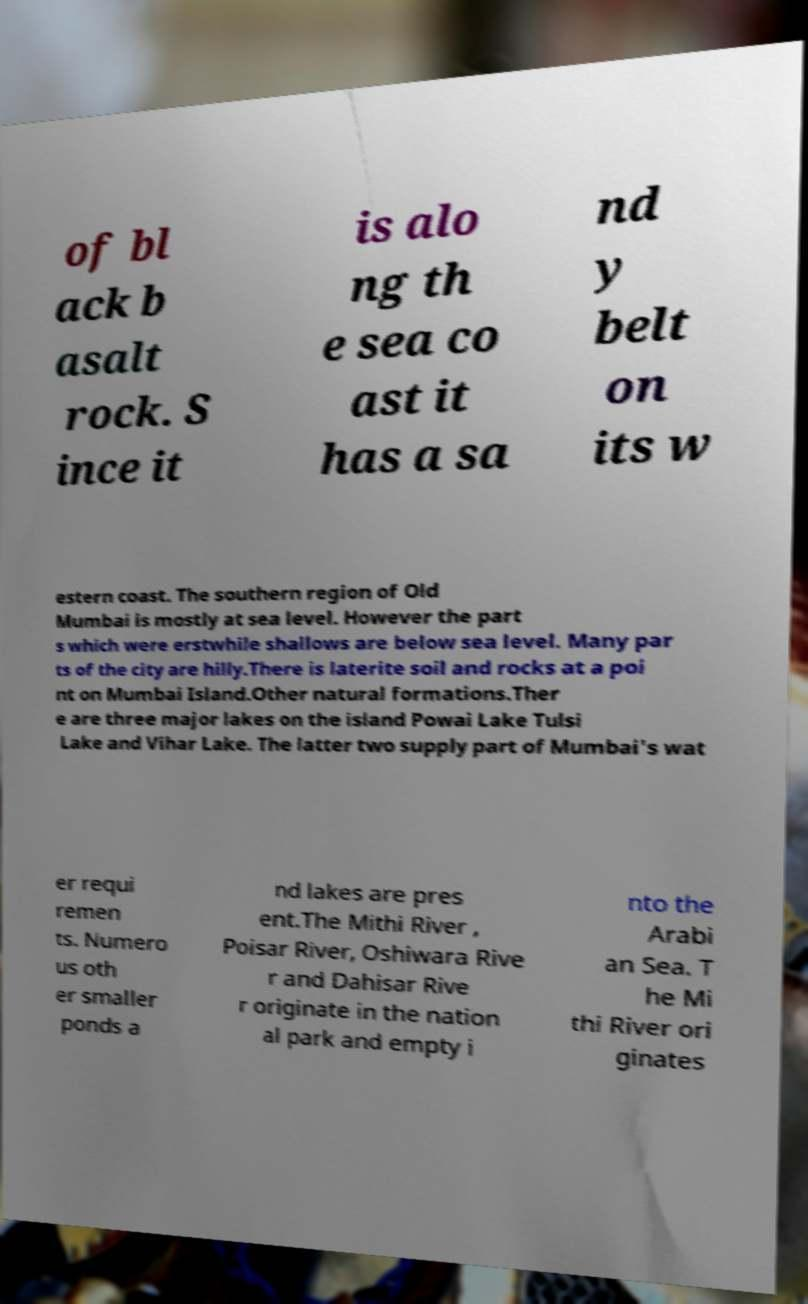Please identify and transcribe the text found in this image. of bl ack b asalt rock. S ince it is alo ng th e sea co ast it has a sa nd y belt on its w estern coast. The southern region of Old Mumbai is mostly at sea level. However the part s which were erstwhile shallows are below sea level. Many par ts of the city are hilly.There is laterite soil and rocks at a poi nt on Mumbai Island.Other natural formations.Ther e are three major lakes on the island Powai Lake Tulsi Lake and Vihar Lake. The latter two supply part of Mumbai's wat er requi remen ts. Numero us oth er smaller ponds a nd lakes are pres ent.The Mithi River , Poisar River, Oshiwara Rive r and Dahisar Rive r originate in the nation al park and empty i nto the Arabi an Sea. T he Mi thi River ori ginates 